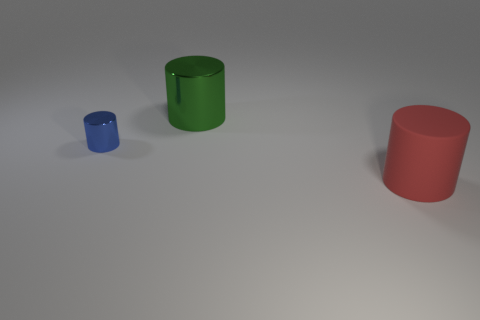There is a metal cylinder right of the blue cylinder; what color is it?
Provide a short and direct response. Green. Are there any cylinders in front of the metallic cylinder behind the tiny blue thing?
Offer a terse response. Yes. Do the matte thing and the metallic object that is behind the small blue object have the same shape?
Offer a terse response. Yes. What size is the object that is to the right of the small shiny cylinder and in front of the big green shiny cylinder?
Your answer should be compact. Large. Are there any blue things that have the same material as the large red object?
Your answer should be very brief. No. There is a large cylinder in front of the object that is on the left side of the green metal cylinder; what is its material?
Make the answer very short. Rubber. There is another object that is the same material as the tiny thing; what is its size?
Offer a terse response. Large. What is the shape of the thing that is on the left side of the large green cylinder?
Provide a succinct answer. Cylinder. There is a matte thing that is the same shape as the big green metal thing; what is its size?
Ensure brevity in your answer.  Large. How many red matte things are to the left of the shiny object in front of the large cylinder that is behind the matte thing?
Keep it short and to the point. 0. 